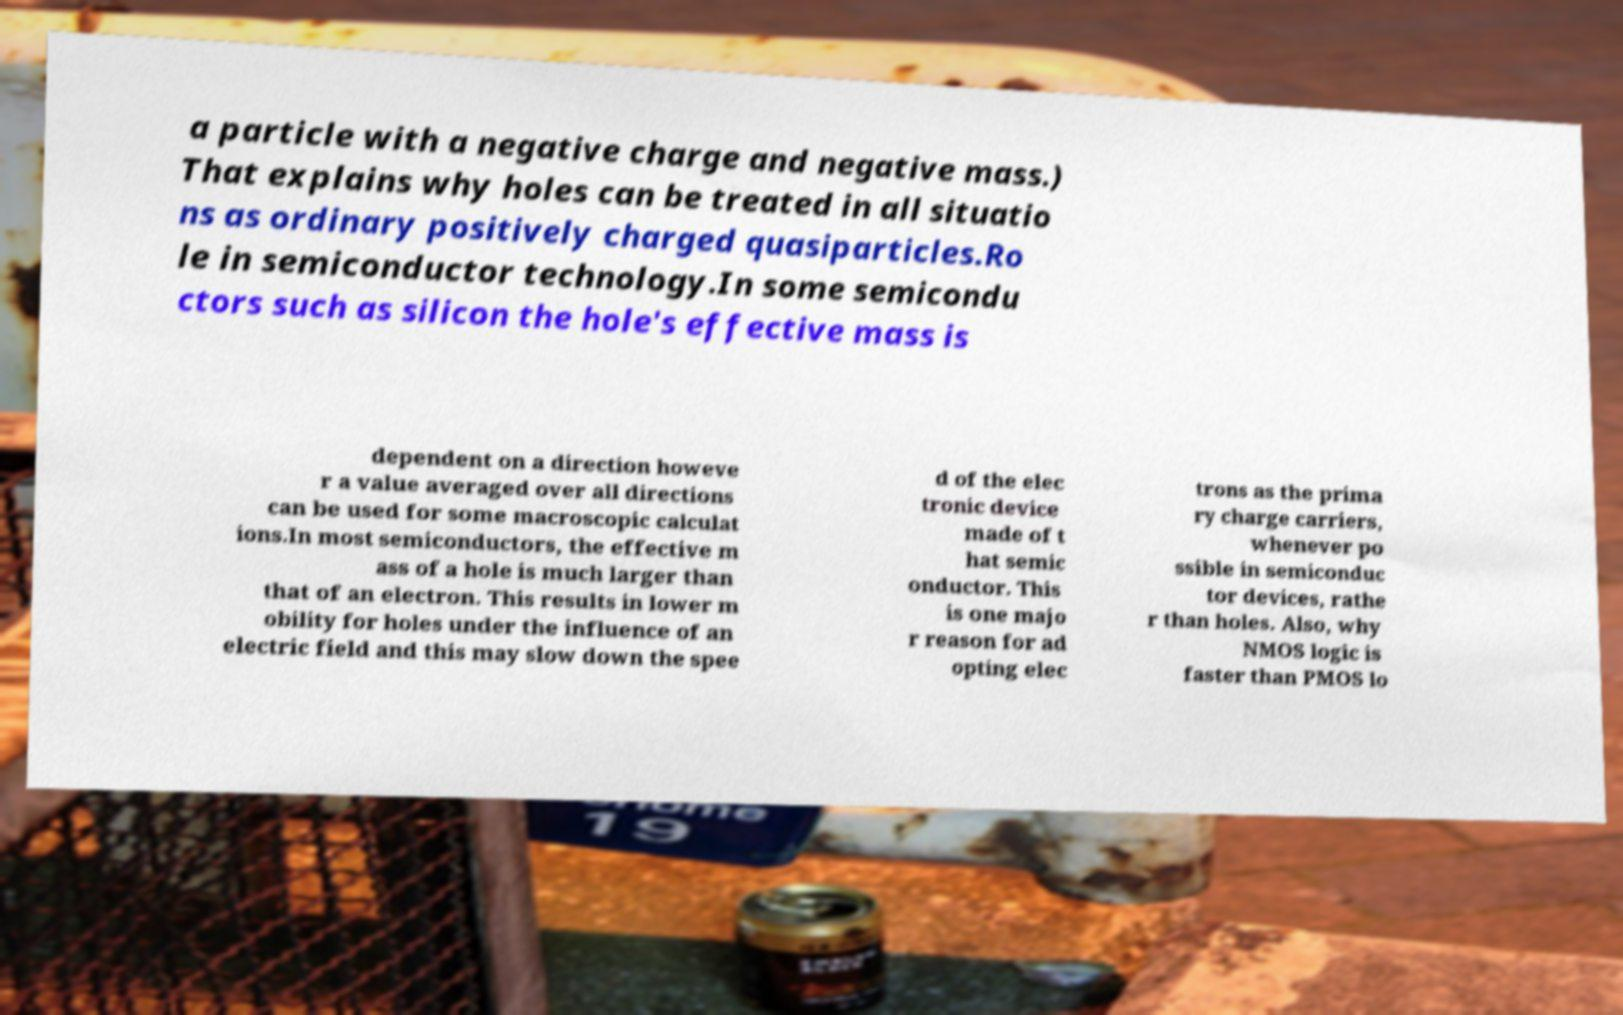Could you assist in decoding the text presented in this image and type it out clearly? a particle with a negative charge and negative mass.) That explains why holes can be treated in all situatio ns as ordinary positively charged quasiparticles.Ro le in semiconductor technology.In some semicondu ctors such as silicon the hole's effective mass is dependent on a direction howeve r a value averaged over all directions can be used for some macroscopic calculat ions.In most semiconductors, the effective m ass of a hole is much larger than that of an electron. This results in lower m obility for holes under the influence of an electric field and this may slow down the spee d of the elec tronic device made of t hat semic onductor. This is one majo r reason for ad opting elec trons as the prima ry charge carriers, whenever po ssible in semiconduc tor devices, rathe r than holes. Also, why NMOS logic is faster than PMOS lo 